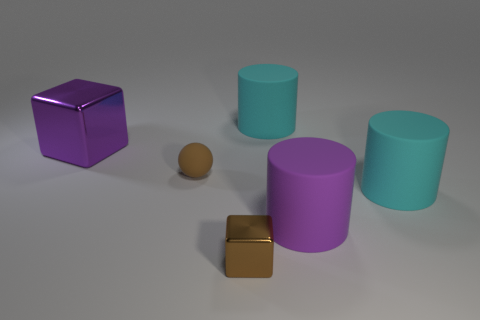Which objects in this image would you say have the same shape? The objects in the image with the same shape are the two cylinders that have a similar form, distinguished only by their size and color. Additionally, the two cubes are of similar shape but differ in size and material finish. Could you deduce the relative sizes of these shapes? Yes, the larger purple cube is the biggest object in the scene, followed by the bigger cylinder. The smaller cylinder and the smaller cube are similar in size but the cube is slightly bigger than the cylinder, and the smallest object is the sphere. 